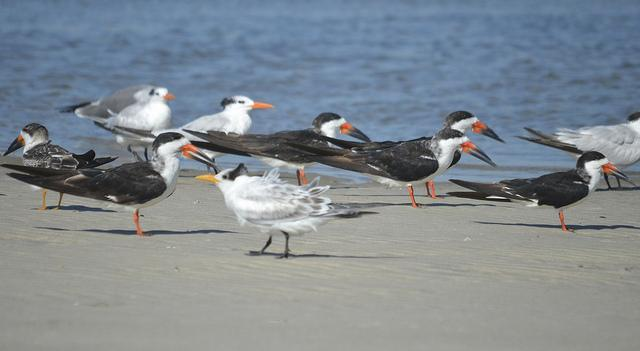What part does this animal have that is absent in humans?

Choices:
A) exoskeleton
B) wings
C) quills
D) stinger wings 